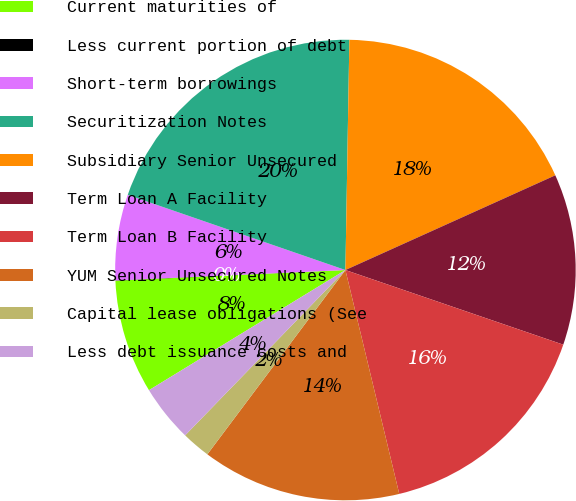<chart> <loc_0><loc_0><loc_500><loc_500><pie_chart><fcel>Current maturities of<fcel>Less current portion of debt<fcel>Short-term borrowings<fcel>Securitization Notes<fcel>Subsidiary Senior Unsecured<fcel>Term Loan A Facility<fcel>Term Loan B Facility<fcel>YUM Senior Unsecured Notes<fcel>Capital lease obligations (See<fcel>Less debt issuance costs and<nl><fcel>8.0%<fcel>0.02%<fcel>6.01%<fcel>19.98%<fcel>17.98%<fcel>12.0%<fcel>15.99%<fcel>13.99%<fcel>2.02%<fcel>4.01%<nl></chart> 